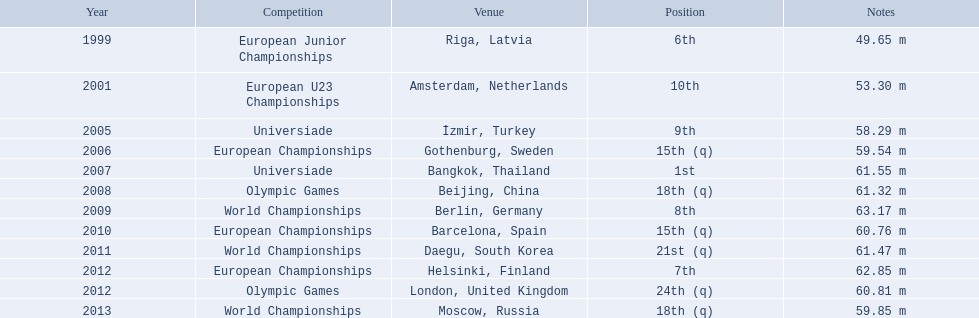What european junior championships? 6th. What waseuropean junior championships best result? 63.17 m. What are all the different contests? European Junior Championships, European U23 Championships, Universiade, European Championships, Universiade, Olympic Games, World Championships, European Championships, World Championships, European Championships, Olympic Games, World Championships. During which years did they end up in the top 10? 1999, 2001, 2005, 2007, 2009, 2012. Apart from when they won, what was their best standing? 6th. 